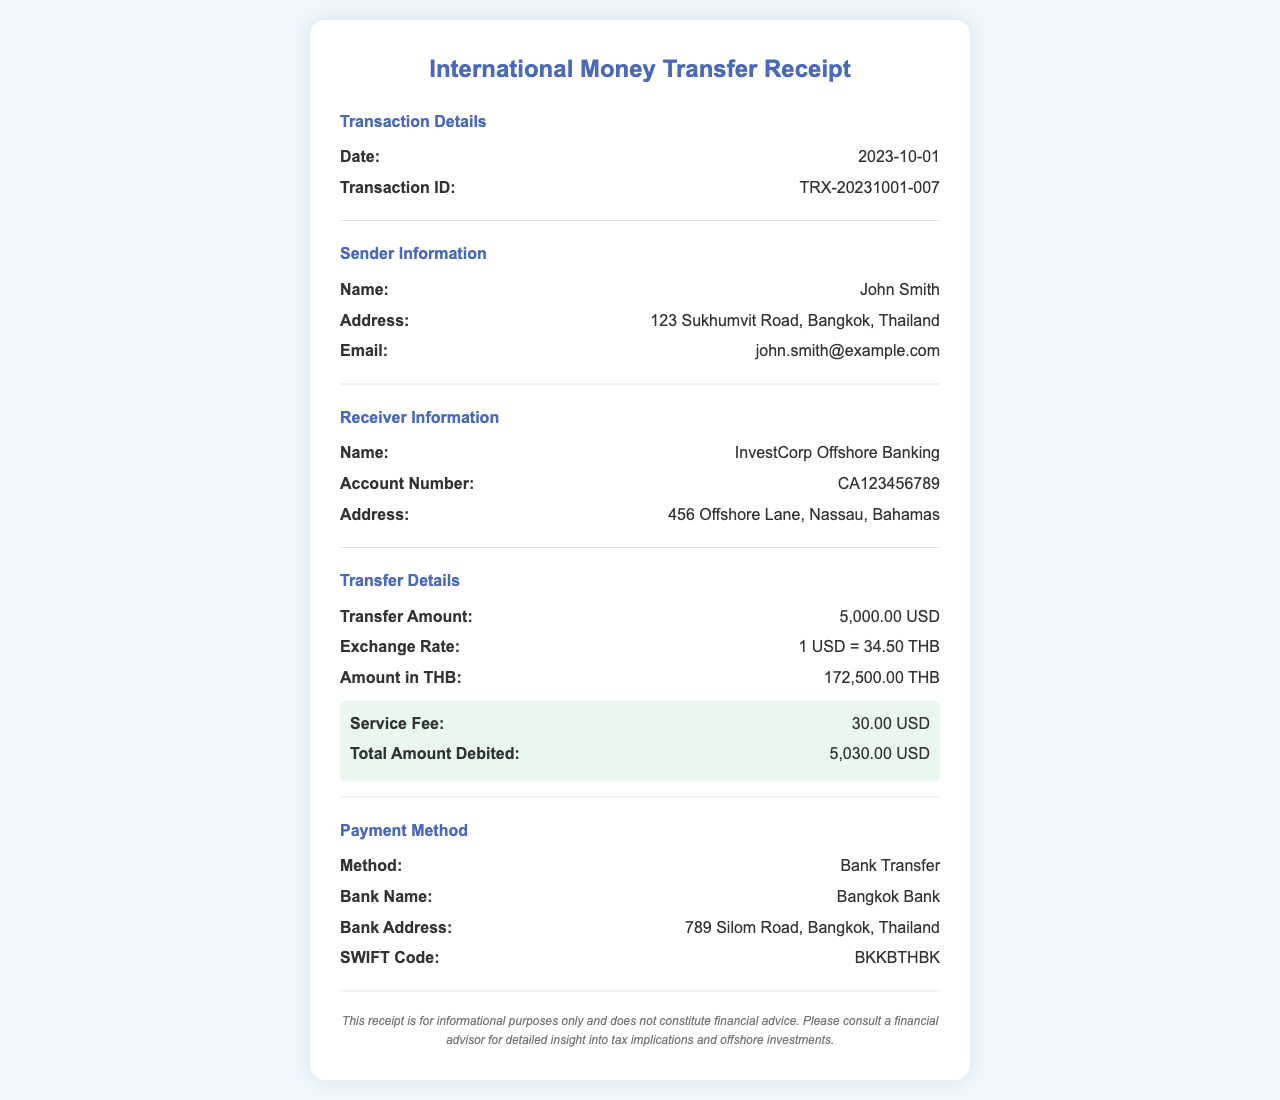What is the transaction date? The transaction date is noted under Transaction Details in the document.
Answer: 2023-10-01 What is the transaction ID? The transaction ID is provided in the Transaction Details section.
Answer: TRX-20231001-007 Who is the sender? The sender's name is provided in the Sender Information section.
Answer: John Smith What is the transfer amount? The transfer amount is listed under Transfer Details in the document.
Answer: 5,000.00 USD What is the exchange rate? The exchange rate is found in the Transfer Details section of the receipt.
Answer: 1 USD = 34.50 THB What is the service fee for this transaction? The service fee is highlighted in the Transfer Details section.
Answer: 30.00 USD What is the total amount debited? The total amount debited is noted in the Transfer Details section.
Answer: 5,030.00 USD What is the payment method used? The payment method is provided in the Payment Method section of the document.
Answer: Bank Transfer What is the SWIFT code of the bank? The SWIFT code is mentioned in the Payment Method section of the receipt.
Answer: BKKBTHBK Which bank processed the transfer? The bank that processed the transfer is listed under Payment Method information.
Answer: Bangkok Bank 